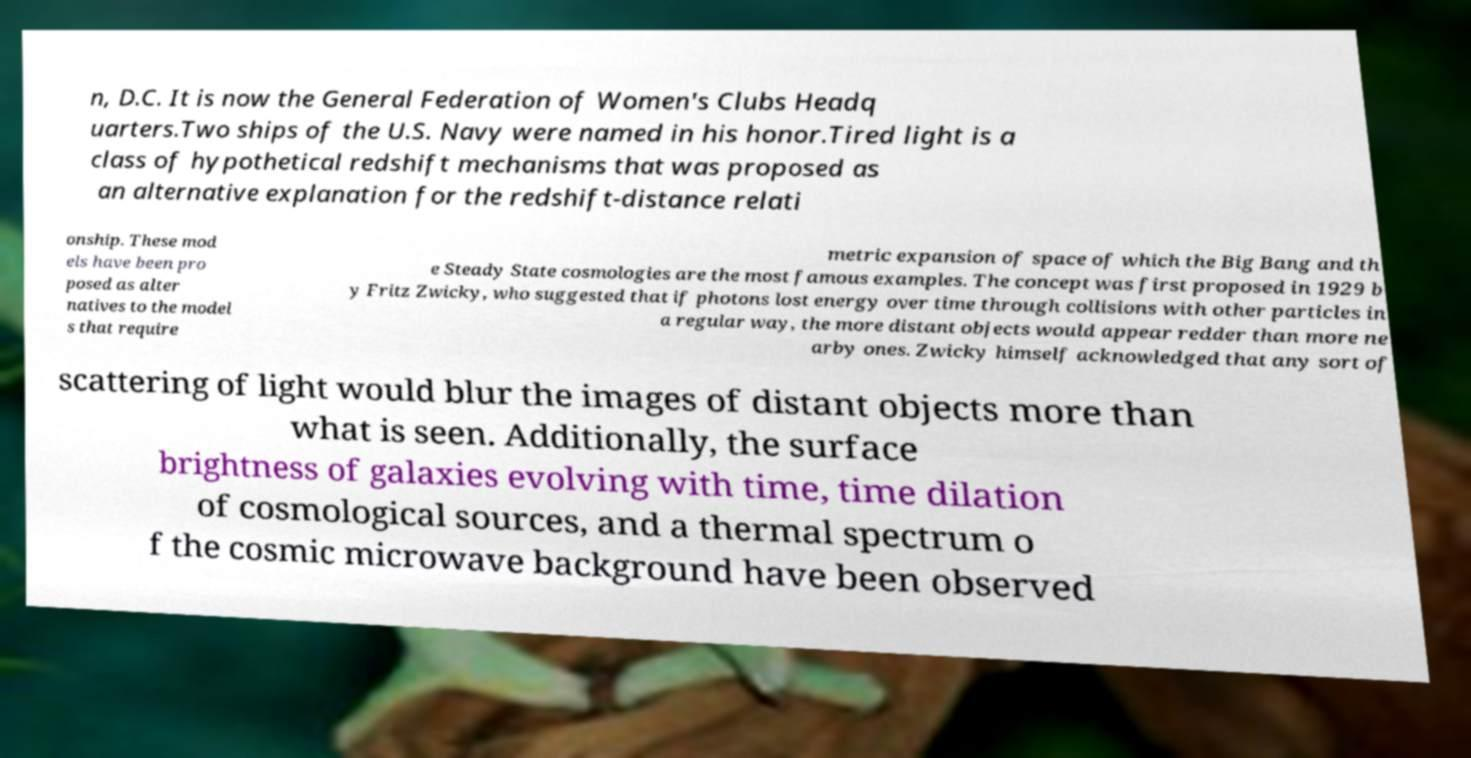Can you read and provide the text displayed in the image?This photo seems to have some interesting text. Can you extract and type it out for me? n, D.C. It is now the General Federation of Women's Clubs Headq uarters.Two ships of the U.S. Navy were named in his honor.Tired light is a class of hypothetical redshift mechanisms that was proposed as an alternative explanation for the redshift-distance relati onship. These mod els have been pro posed as alter natives to the model s that require metric expansion of space of which the Big Bang and th e Steady State cosmologies are the most famous examples. The concept was first proposed in 1929 b y Fritz Zwicky, who suggested that if photons lost energy over time through collisions with other particles in a regular way, the more distant objects would appear redder than more ne arby ones. Zwicky himself acknowledged that any sort of scattering of light would blur the images of distant objects more than what is seen. Additionally, the surface brightness of galaxies evolving with time, time dilation of cosmological sources, and a thermal spectrum o f the cosmic microwave background have been observed 